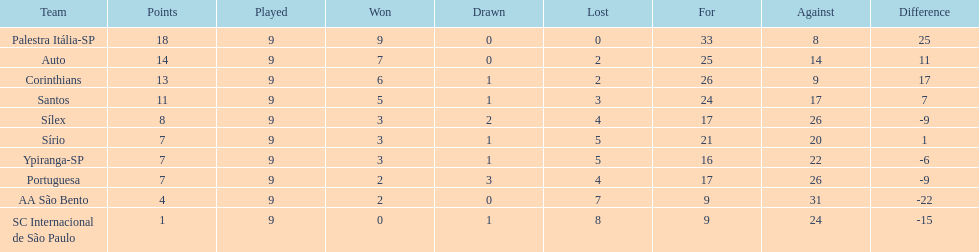Could you help me parse every detail presented in this table? {'header': ['Team', 'Points', 'Played', 'Won', 'Drawn', 'Lost', 'For', 'Against', 'Difference'], 'rows': [['Palestra Itália-SP', '18', '9', '9', '0', '0', '33', '8', '25'], ['Auto', '14', '9', '7', '0', '2', '25', '14', '11'], ['Corinthians', '13', '9', '6', '1', '2', '26', '9', '17'], ['Santos', '11', '9', '5', '1', '3', '24', '17', '7'], ['Sílex', '8', '9', '3', '2', '4', '17', '26', '-9'], ['Sírio', '7', '9', '3', '1', '5', '21', '20', '1'], ['Ypiranga-SP', '7', '9', '3', '1', '5', '16', '22', '-6'], ['Portuguesa', '7', '9', '2', '3', '4', '17', '26', '-9'], ['AA São Bento', '4', '9', '2', '0', '7', '9', '31', '-22'], ['SC Internacional de São Paulo', '1', '9', '0', '1', '8', '9', '24', '-15']]} Which brazilian team took the top spot in the 1926 brazilian football cup? Palestra Itália-SP. 